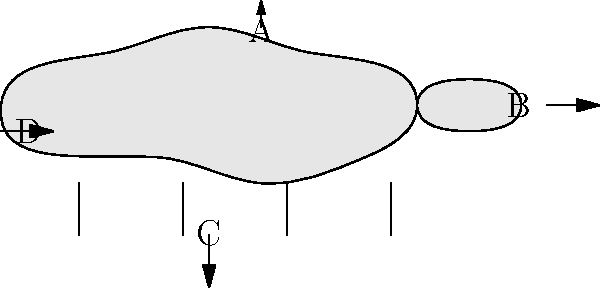In the diagram of a pit pony, which labeled feature (A, B, C, or D) represents the adaptation that allowed these animals to work in low-ceiling mine shafts? To answer this question, let's examine each labeled feature and its relevance to working in low-ceiling mine shafts:

1. Feature A: This points to the pony's back. While important, it's not specifically adapted for low ceilings.

2. Feature B: This indicates the pony's head. Again, while crucial, it's not uniquely adapted for mine work.

3. Feature C: This points to the pony's legs. Pit ponies did have strong, sturdy legs, but this wasn't a specific adaptation for low ceilings.

4. Feature D: This highlights the pony's overall small stature. This is the key adaptation that allowed pit ponies to work in low-ceiling mine shafts.

Pit ponies were specifically bred and selected to be smaller than average horses. Their diminutive size, typically standing no taller than 12 hands (48 inches or 122 cm) at the withers, was crucial for navigating the confined spaces of underground mines. This small stature allowed them to pull carts of coal through low tunnels without bumping their heads or backs on the ceiling.

Therefore, the feature that represents the adaptation allowing these animals to work in low-ceiling mine shafts is D, indicating the pony's overall small size.
Answer: D 